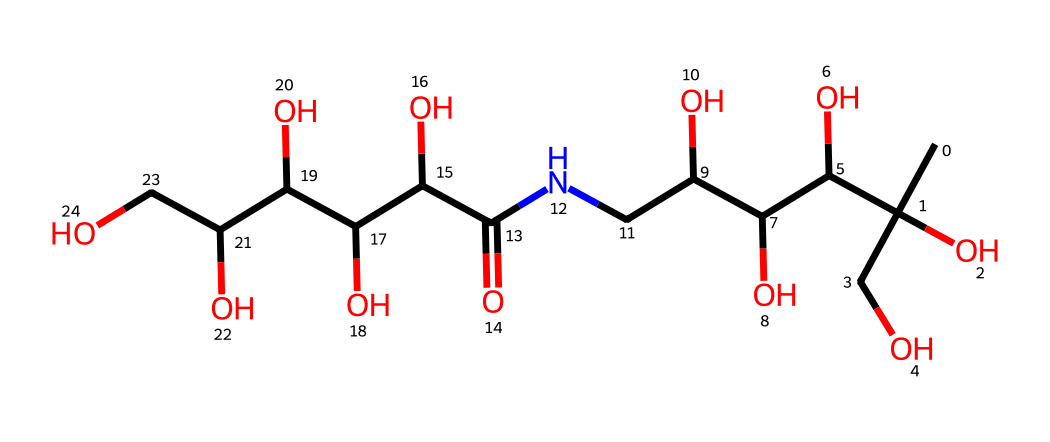How many carbon atoms are in this chemical? By examining the SMILES representation, there are 10 instances of "C," indicating the presence of 10 carbon atoms in the chemical.
Answer: 10 What functional groups are present in this molecule? Looking at the structure, there are multiple hydroxyl (–OH) groups along with an amide (–C(=O)N–) group present in the compound.
Answer: hydroxyl, amide How many hydroxyl groups are in this chemical? The molecule has five distinct –OH (hydroxyl) groups, which can be counted in the structure provided by the SMILES.
Answer: 5 What type of chemical is this primarily used for? The structure indicates the presence of hydrophilic functional groups, specifically used for moisture retention, categorizing it as a hydrating compound often used in moisturizers.
Answer: moisturizer What is the molecular formula of this chemical? The SMILES can be analyzed to derive the molecular formula, which consists of 10 carbon (C), 17 hydrogen (H), 3 nitrogen (N), and 6 oxygen (O) atoms, forming C10H17N3O6.
Answer: C10H17N3O6 What does the presence of nitrogen indicate about this chemical? The nitrogen (N) present in the structure contributes to the classification of this compound as an amino acid derivative, which can affect its biological activity and interactions in formulations.
Answer: amino acid derivative 